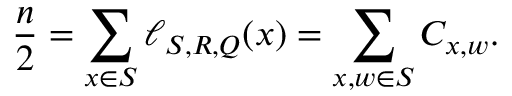<formula> <loc_0><loc_0><loc_500><loc_500>\frac { n } { 2 } = \sum _ { x \in S } \ell _ { S , R , Q } ( x ) = \sum _ { x , w \in S } C _ { x , w } .</formula> 